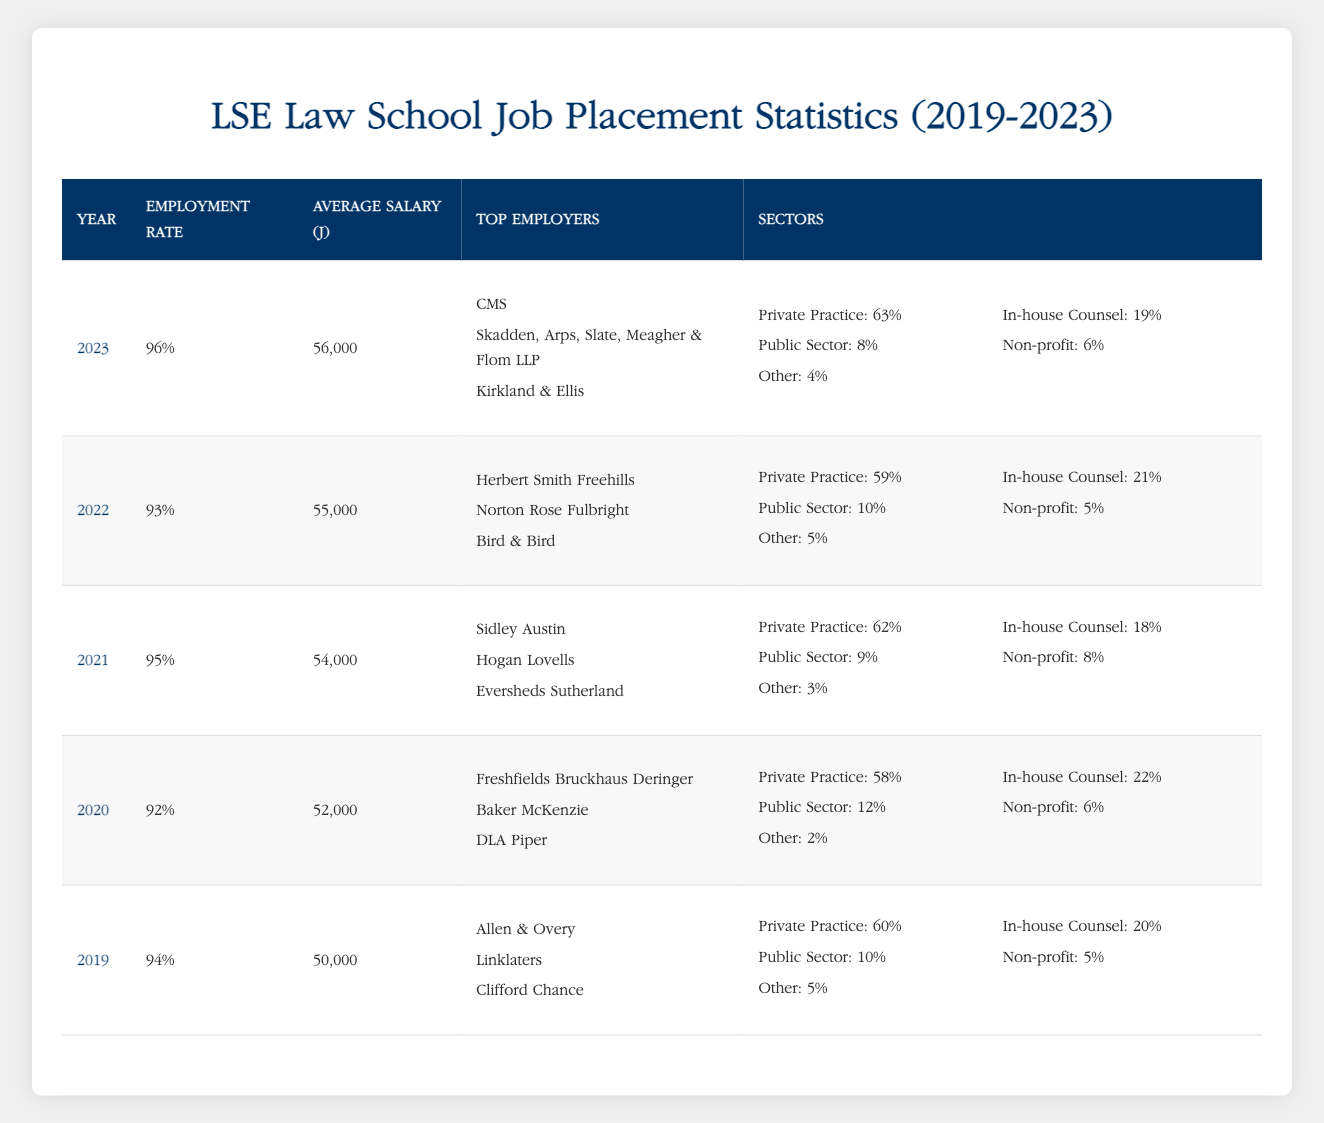What was the employment rate of LSE Law School graduates in 2021? The table shows that the employment rate for the year 2021 is listed directly under the "Employment Rate" column for that row, which indicates it is 95%.
Answer: 95% Which year had the highest average salary? By examining the "Average Salary (£)" column across all the years, we find that 2023 has the highest value listed, which is £56,000.
Answer: £56,000 How many graduates were employed in the public sector in 2020? The data for 2020 shows that the public sector employment rate is 12%, which means 12% of graduates were employed in this sector.
Answer: 12% What is the average employment rate over the five years? To find the average employment rate, we sum the employment rates for each year (94 + 92 + 95 + 93 + 96 = 470) and divide by the number of years (5), which gives an average of 94%.
Answer: 94% Did the employment rate increase from 2019 to 2023? By comparing the employment rates of 2019 (94%) and 2023 (96%), it is clear that the employment rate did increase over this time period.
Answer: Yes What percentage of graduates worked in private practice in 2022? The table indicates that in 2022, 59% of the graduates were employed in private practice, as shown in the "Sectors" column for that year.
Answer: 59% Which year saw a decrease in average salary compared to the previous year? Comparing the average salaries year-over-year, we see that the average salary decreased from £54,000 in 2021 to £52,000 in 2020.
Answer: 2020 How many top employers were listed for the year 2022? The table lists three top employers for 2022: Herbert Smith Freehills, Norton Rose Fulbright, and Bird & Bird. Therefore, the number of top employers is 3.
Answer: 3 What was the sector distribution for in-house counsel over the five years? To find the sector distribution for in-house counsel, we can see the values: 20% in 2019, 22% in 2020, 18% in 2021, 21% in 2022, and 19% in 2023. The distribution shows some fluctuation but consistently falls between 18% and 22%.
Answer: Fluctuating between 18% and 22% 